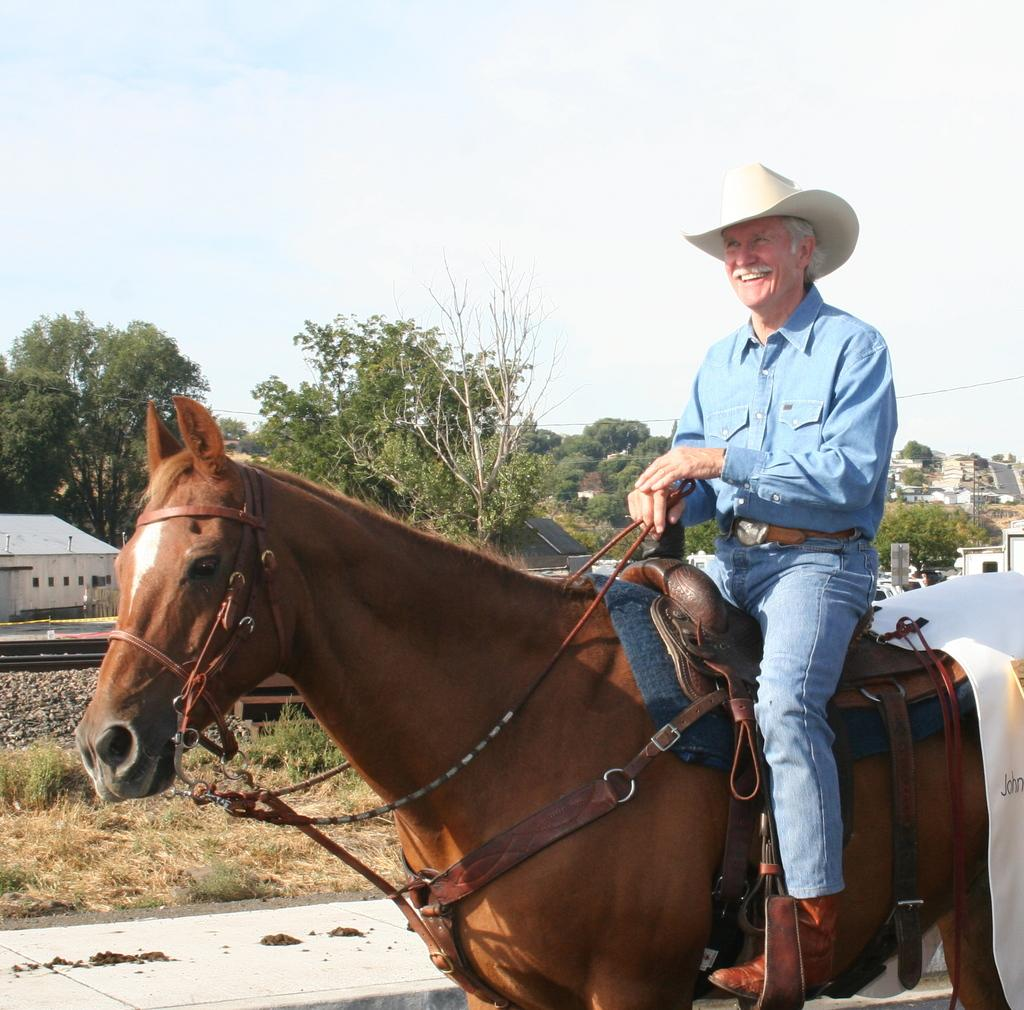Who is the main subject in the picture? There is an old man in the picture. What is the old man doing in the image? The old man is riding a horse. What is the old man wearing in the image? The old man is wearing blue denim pants, a blue shirt, and a hat. What can be seen in the distance in the image? There are plants and trees in the distance. How would you describe the weather in the image? The sky is cloudy in the image. What type of oven can be seen in the image? There is no oven present in the image. How many employees does the company have in the image? There is no company or employees mentioned or depicted in the image. 